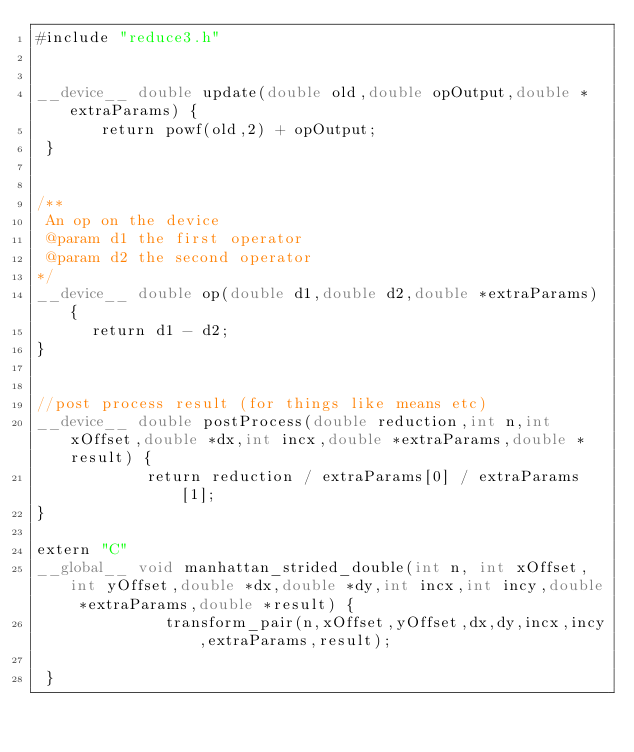Convert code to text. <code><loc_0><loc_0><loc_500><loc_500><_Cuda_>#include "reduce3.h"


__device__ double update(double old,double opOutput,double *extraParams) {
       return powf(old,2) + opOutput;
 }


/**
 An op on the device
 @param d1 the first operator
 @param d2 the second operator
*/
__device__ double op(double d1,double d2,double *extraParams) {
      return d1 - d2;
}


//post process result (for things like means etc)
__device__ double postProcess(double reduction,int n,int xOffset,double *dx,int incx,double *extraParams,double *result) {
            return reduction / extraParams[0] / extraParams[1];
}

extern "C"
__global__ void manhattan_strided_double(int n, int xOffset,int yOffset,double *dx,double *dy,int incx,int incy,double *extraParams,double *result) {
              transform_pair(n,xOffset,yOffset,dx,dy,incx,incy,extraParams,result);

 }


</code> 